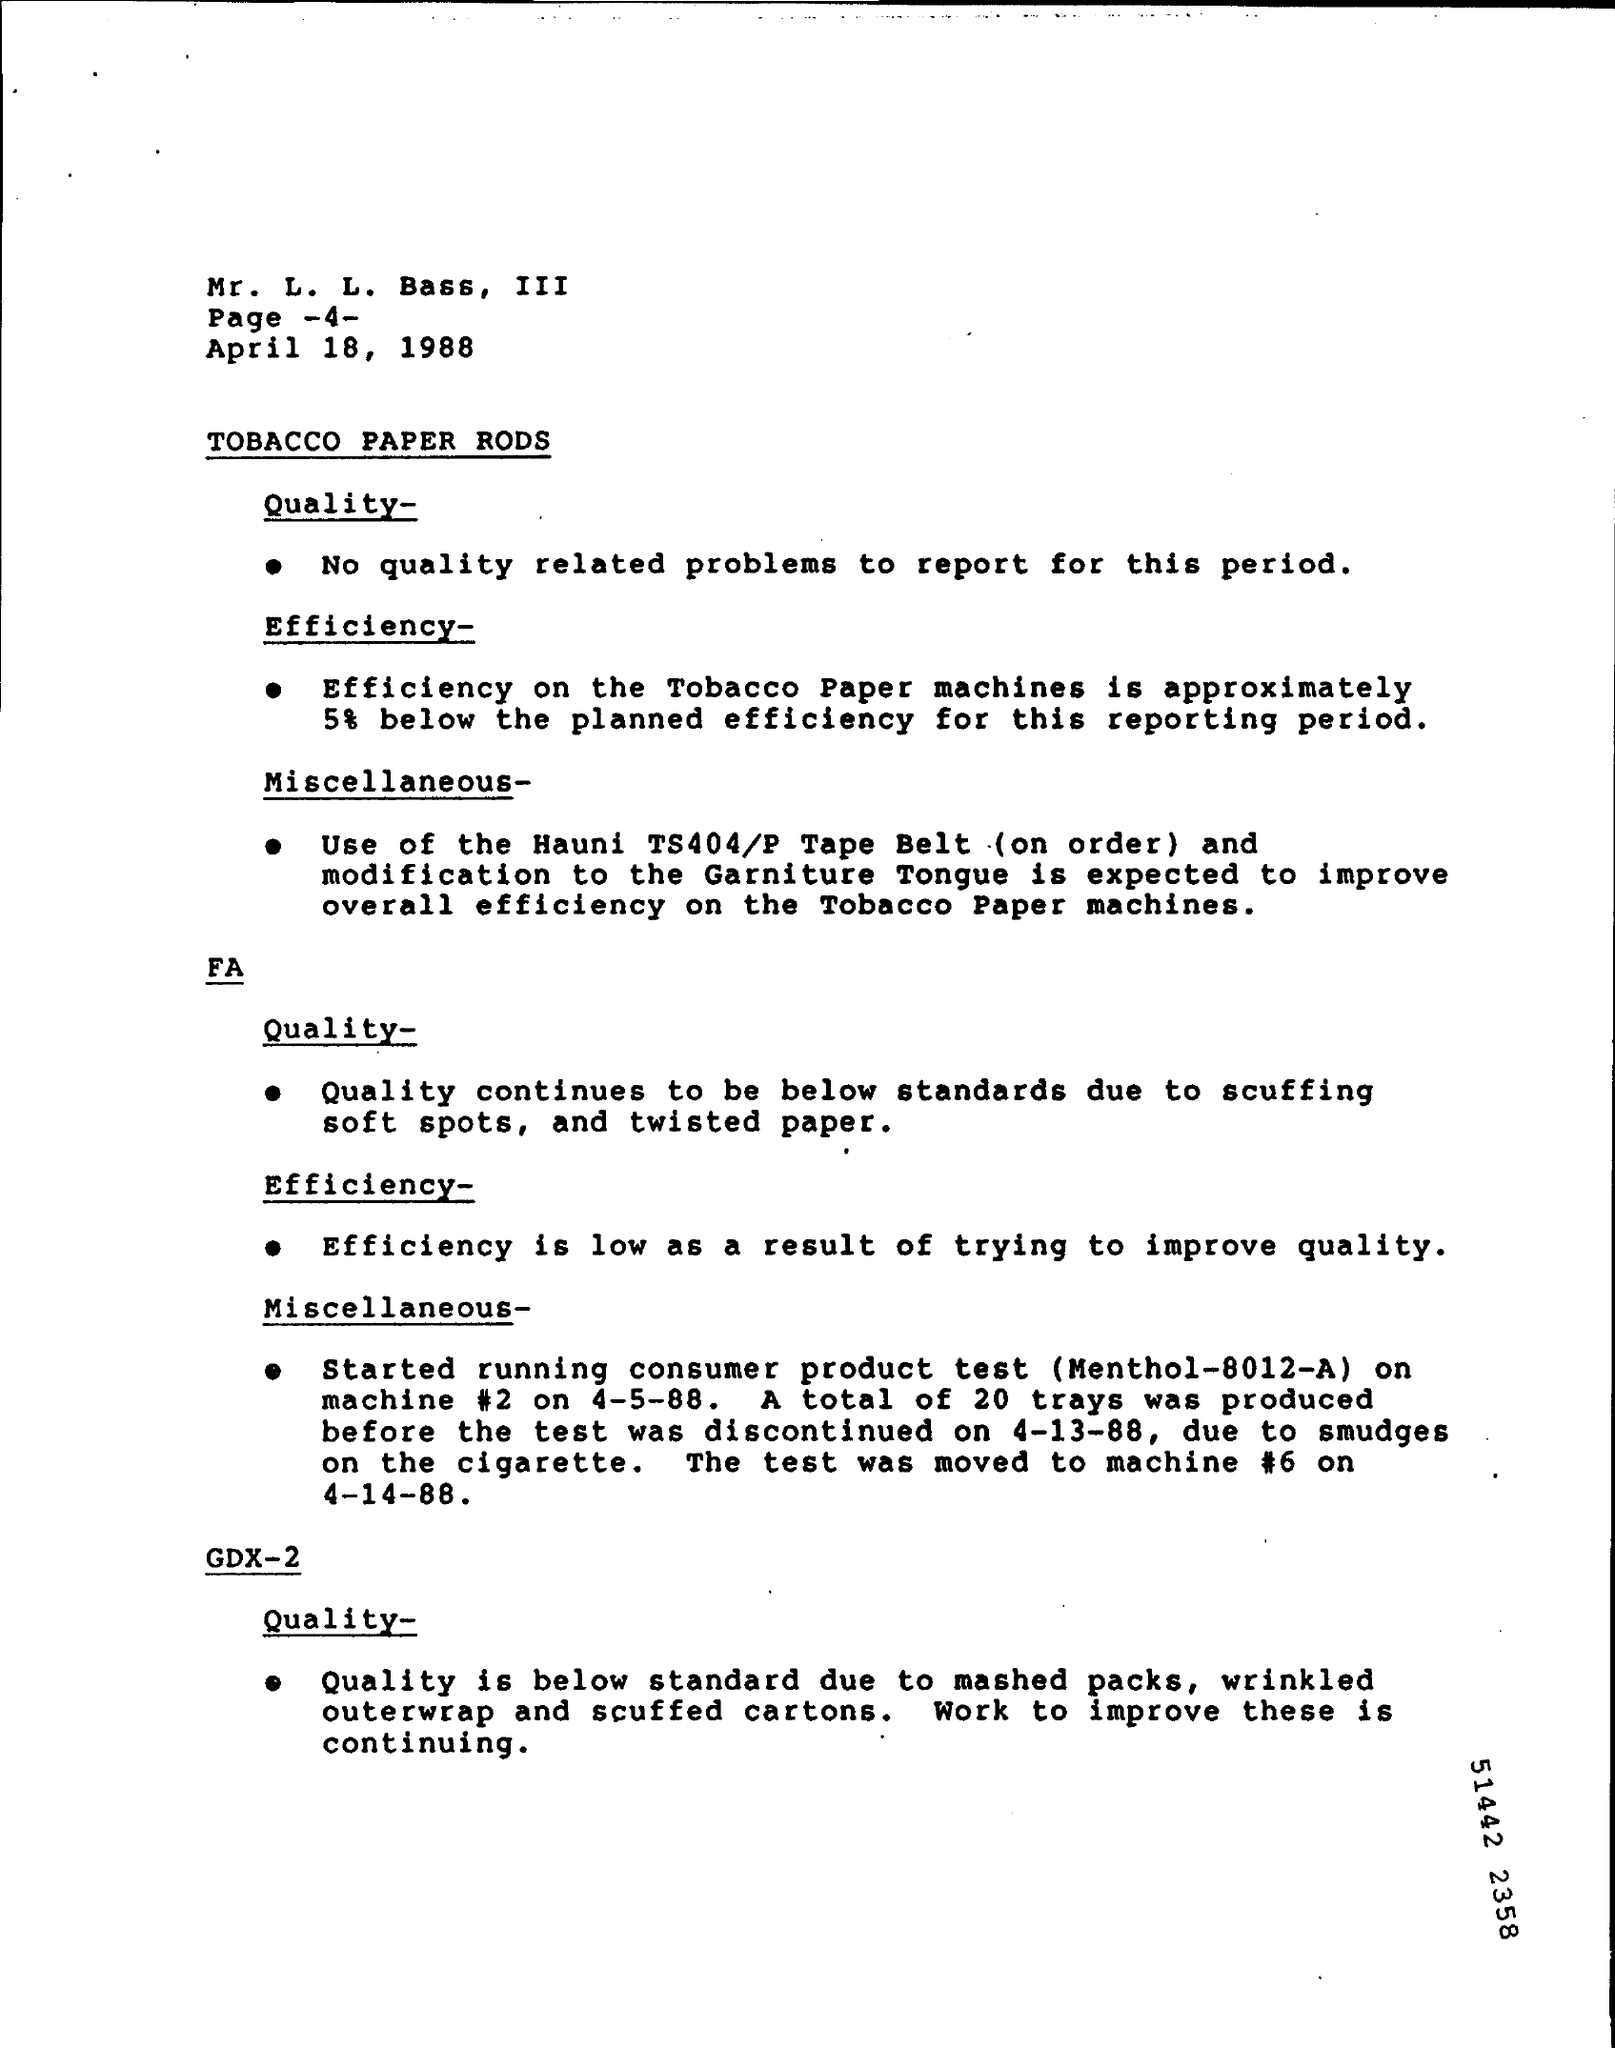What is the page no mentioned ?
Your answer should be compact. 4. On which date  the test moved to machine #6
Provide a short and direct response. 4-14-88. Efficiency is low as a result of what ?
Ensure brevity in your answer.  Trying to improve quality. 